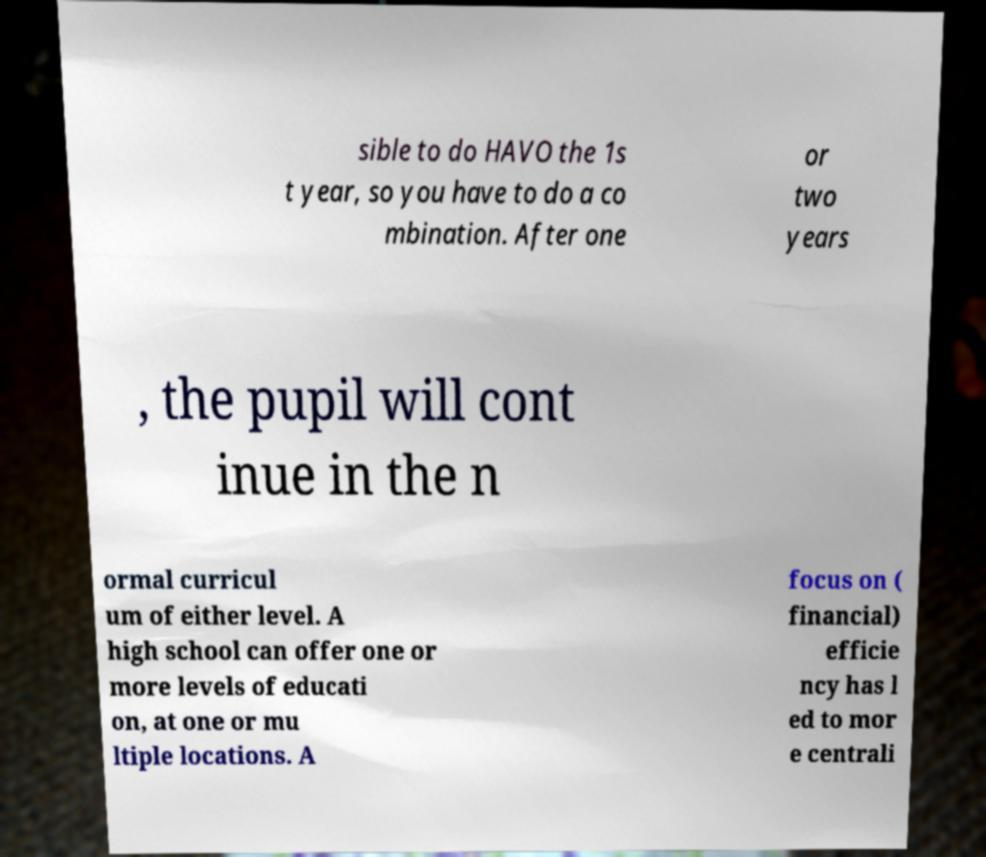For documentation purposes, I need the text within this image transcribed. Could you provide that? sible to do HAVO the 1s t year, so you have to do a co mbination. After one or two years , the pupil will cont inue in the n ormal curricul um of either level. A high school can offer one or more levels of educati on, at one or mu ltiple locations. A focus on ( financial) efficie ncy has l ed to mor e centrali 